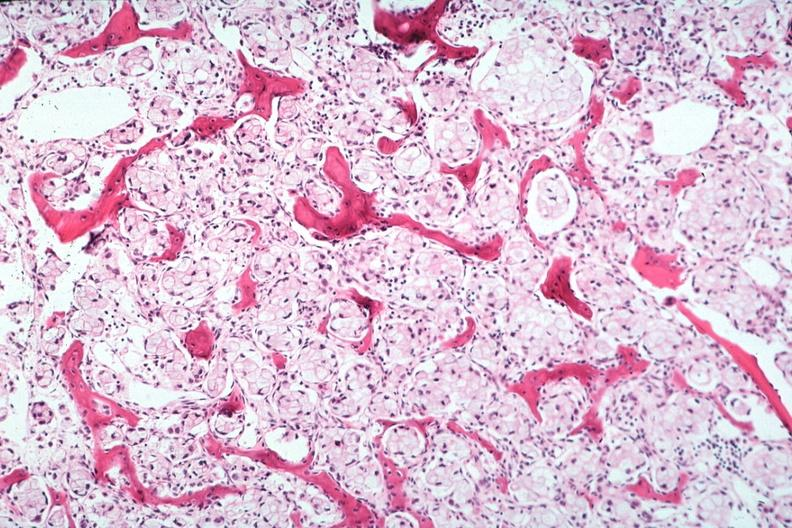what is present?
Answer the question using a single word or phrase. Joints 